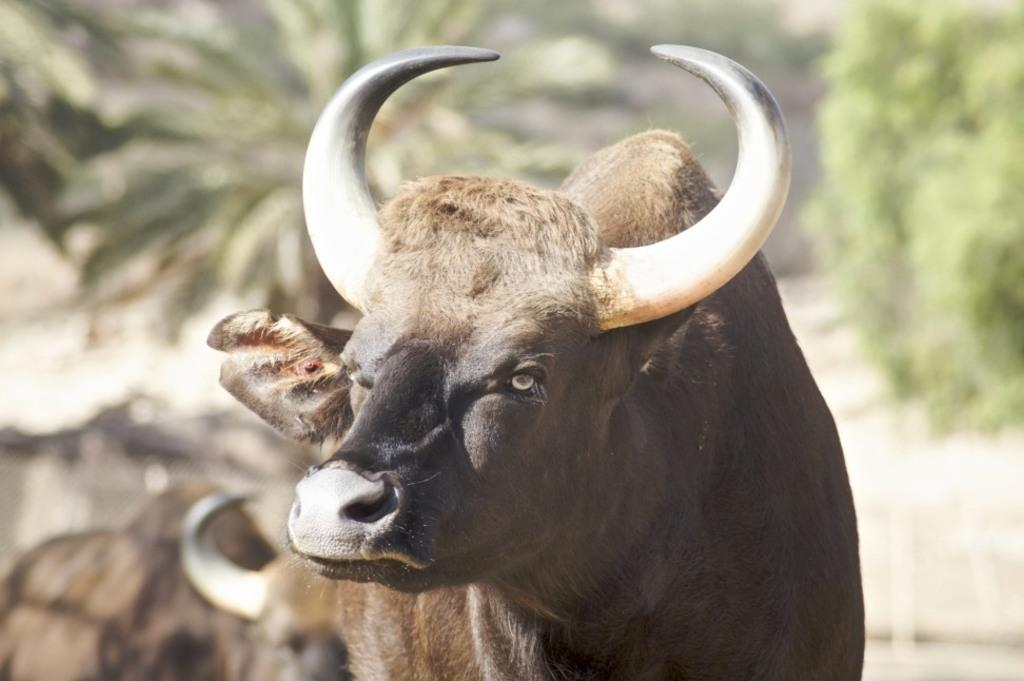What type of animals are in the image? There are wild bulls in the image. Can you describe the color of the bulls? The bulls are brown and black in color. What can be seen in the background of the image? There are trees visible in the image. What type of copper material is used to build the school in the image? There is no school or copper material present in the image; it features wild bulls and trees. 